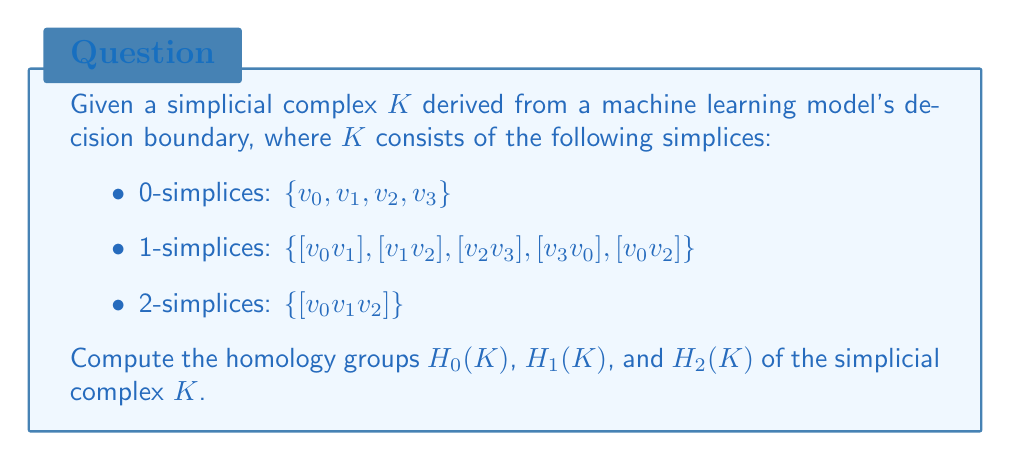Help me with this question. To compute the homology groups, we'll follow these steps:

1. Construct the chain complex
2. Compute the boundary matrices
3. Find the kernels and images of the boundary maps
4. Calculate the homology groups

Step 1: Construct the chain complex

The chain complex for $K$ is:

$$C_2 \xrightarrow{\partial_2} C_1 \xrightarrow{\partial_1} C_0 \xrightarrow{\partial_0} 0$$

Where:
$C_2 = \mathbb{Z}$ (1 2-simplex)
$C_1 = \mathbb{Z}^5$ (5 1-simplices)
$C_0 = \mathbb{Z}^4$ (4 0-simplices)

Step 2: Compute the boundary matrices

$\partial_2: C_2 \to C_1$
$$\partial_2([v_0v_1v_2]) = [v_1v_2] - [v_0v_2] + [v_0v_1]$$

$\partial_1: C_1 \to C_0$
$$\begin{align*}
\partial_1([v_0v_1]) &= v_1 - v_0 \\
\partial_1([v_1v_2]) &= v_2 - v_1 \\
\partial_1([v_2v_3]) &= v_3 - v_2 \\
\partial_1([v_3v_0]) &= v_0 - v_3 \\
\partial_1([v_0v_2]) &= v_2 - v_0
\end{align*}$$

Step 3: Find kernels and images

$\ker \partial_1 = \{a[v_0v_1] + b[v_1v_2] + c[v_2v_3] + d[v_3v_0] + e[v_0v_2] \mid a+b+c+d+e = 0\}$
$\text{im } \partial_2 = \{a([v_1v_2] - [v_0v_2] + [v_0v_1]) \mid a \in \mathbb{Z}\}$
$\ker \partial_0 = C_0$ (since $\partial_0 = 0$)
$\text{im } \partial_1 = \{av_0 + bv_1 + cv_2 + dv_3 \mid a+b+c+d = 0\}$

Step 4: Calculate homology groups

$H_0(K) = \ker \partial_0 / \text{im } \partial_1 \cong \mathbb{Z}$
$H_1(K) = \ker \partial_1 / \text{im } \partial_2 \cong \mathbb{Z}$
$H_2(K) = \ker \partial_2 / \text{im } \partial_3 = 0$ (since $\partial_3 = 0$ and $\ker \partial_2 = 0$)

The intuition behind these results:
- $H_0(K) \cong \mathbb{Z}$ indicates that $K$ has one connected component.
- $H_1(K) \cong \mathbb{Z}$ shows that $K$ has one 1-dimensional hole (cycle).
- $H_2(K) = 0$ means $K$ has no 2-dimensional holes (voids).
Answer: $H_0(K) \cong \mathbb{Z}$, $H_1(K) \cong \mathbb{Z}$, $H_2(K) = 0$ 